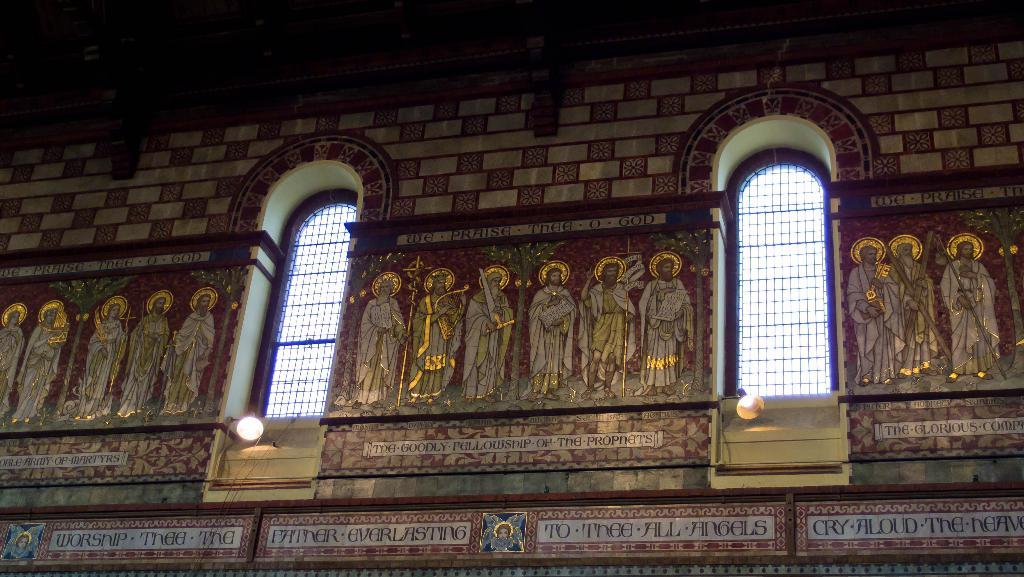What is present on the wall in the image? The wall has pictures of persons on it. Is there any text on the wall? Yes, there is writing on the wall. What can be seen in the image besides the wall? There are lights and windows in the image. What is the rate of the distance between the two windows in the image? There is no information about the distance between the windows or any rate associated with it in the image. 